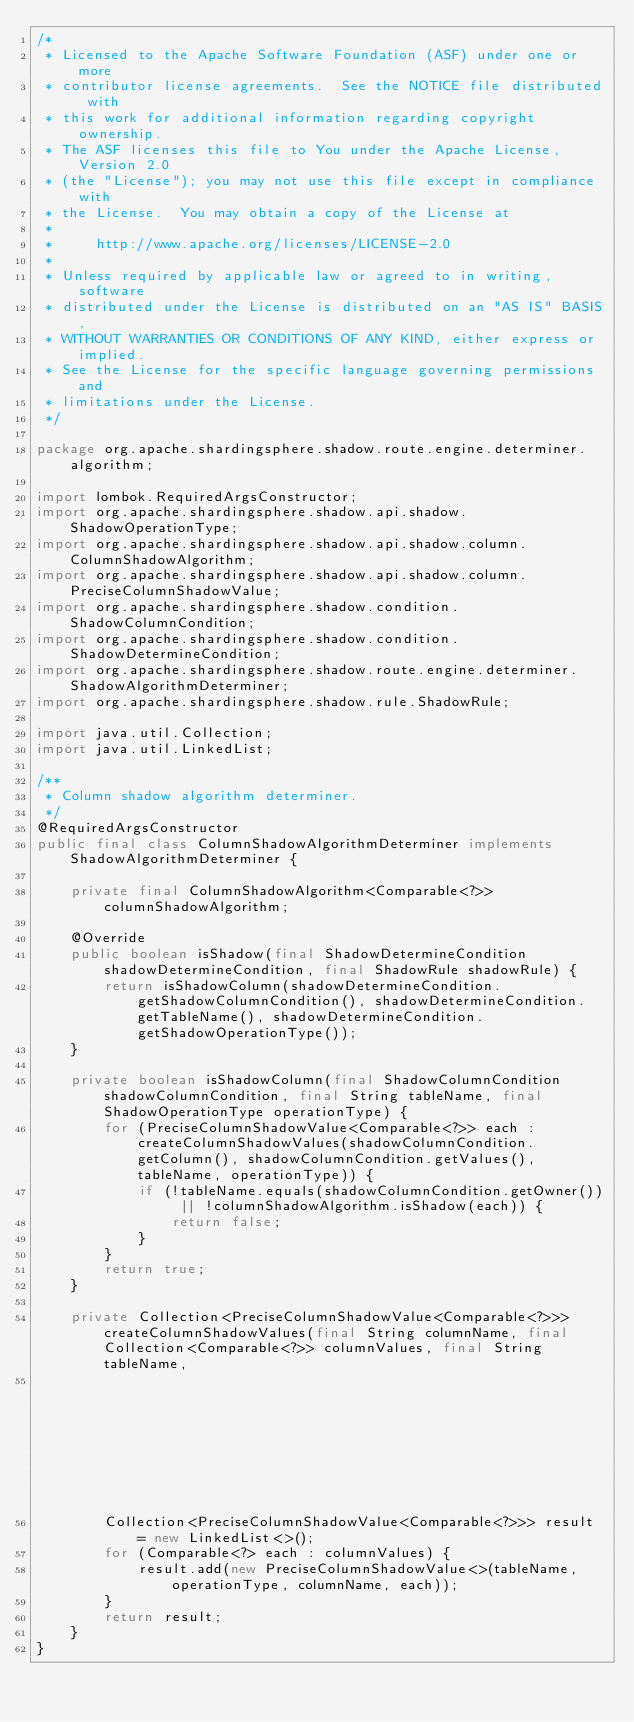<code> <loc_0><loc_0><loc_500><loc_500><_Java_>/*
 * Licensed to the Apache Software Foundation (ASF) under one or more
 * contributor license agreements.  See the NOTICE file distributed with
 * this work for additional information regarding copyright ownership.
 * The ASF licenses this file to You under the Apache License, Version 2.0
 * (the "License"); you may not use this file except in compliance with
 * the License.  You may obtain a copy of the License at
 *
 *     http://www.apache.org/licenses/LICENSE-2.0
 *
 * Unless required by applicable law or agreed to in writing, software
 * distributed under the License is distributed on an "AS IS" BASIS,
 * WITHOUT WARRANTIES OR CONDITIONS OF ANY KIND, either express or implied.
 * See the License for the specific language governing permissions and
 * limitations under the License.
 */

package org.apache.shardingsphere.shadow.route.engine.determiner.algorithm;

import lombok.RequiredArgsConstructor;
import org.apache.shardingsphere.shadow.api.shadow.ShadowOperationType;
import org.apache.shardingsphere.shadow.api.shadow.column.ColumnShadowAlgorithm;
import org.apache.shardingsphere.shadow.api.shadow.column.PreciseColumnShadowValue;
import org.apache.shardingsphere.shadow.condition.ShadowColumnCondition;
import org.apache.shardingsphere.shadow.condition.ShadowDetermineCondition;
import org.apache.shardingsphere.shadow.route.engine.determiner.ShadowAlgorithmDeterminer;
import org.apache.shardingsphere.shadow.rule.ShadowRule;

import java.util.Collection;
import java.util.LinkedList;

/**
 * Column shadow algorithm determiner.
 */
@RequiredArgsConstructor
public final class ColumnShadowAlgorithmDeterminer implements ShadowAlgorithmDeterminer {
    
    private final ColumnShadowAlgorithm<Comparable<?>> columnShadowAlgorithm;
    
    @Override
    public boolean isShadow(final ShadowDetermineCondition shadowDetermineCondition, final ShadowRule shadowRule) {
        return isShadowColumn(shadowDetermineCondition.getShadowColumnCondition(), shadowDetermineCondition.getTableName(), shadowDetermineCondition.getShadowOperationType());
    }
    
    private boolean isShadowColumn(final ShadowColumnCondition shadowColumnCondition, final String tableName, final ShadowOperationType operationType) {
        for (PreciseColumnShadowValue<Comparable<?>> each : createColumnShadowValues(shadowColumnCondition.getColumn(), shadowColumnCondition.getValues(), tableName, operationType)) {
            if (!tableName.equals(shadowColumnCondition.getOwner()) || !columnShadowAlgorithm.isShadow(each)) {
                return false;
            }
        }
        return true;
    }
    
    private Collection<PreciseColumnShadowValue<Comparable<?>>> createColumnShadowValues(final String columnName, final Collection<Comparable<?>> columnValues, final String tableName,
                                                                                         final ShadowOperationType operationType) {
        Collection<PreciseColumnShadowValue<Comparable<?>>> result = new LinkedList<>();
        for (Comparable<?> each : columnValues) {
            result.add(new PreciseColumnShadowValue<>(tableName, operationType, columnName, each));
        }
        return result;
    }
}
</code> 